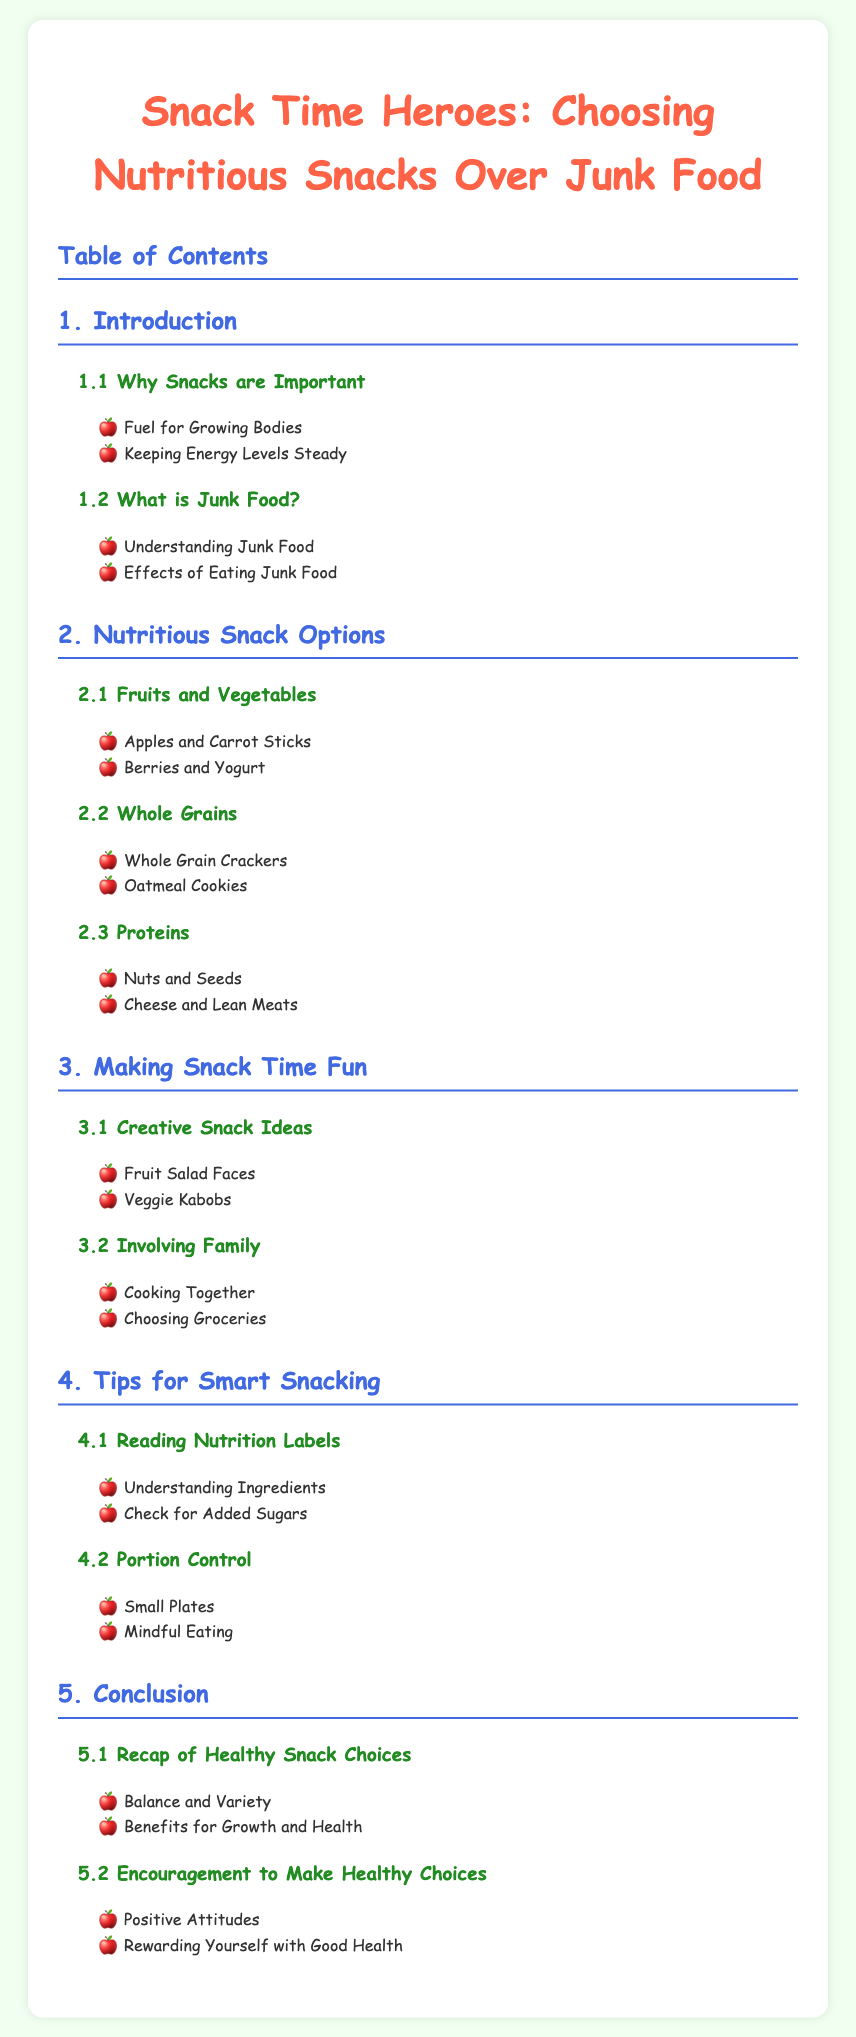What is the title of the document? The title of the document is found at the top and is "Snack Time Heroes: Choosing Nutritious Snacks Over Junk Food."
Answer: Snack Time Heroes: Choosing Nutritious Snacks Over Junk Food How many main sections are in the Table of Contents? The main sections are numbered from 1 to 5, which indicates there are five sections.
Answer: 5 What is one example of nutritious snacks mentioned under "Fruits and Vegetables"? Under "Fruits and Vegetables," one example provided is "Apples and Carrot Sticks."
Answer: Apples and Carrot Sticks What is one creative snack idea mentioned in the document? One creative snack idea listed is "Fruit Salad Faces."
Answer: Fruit Salad Faces What is a tip for smart snacking regarding portion control? The document suggests using "Small Plates" as a tip for portion control.
Answer: Small Plates What should you check for when reading nutrition labels? When reading nutrition labels, it is important to "Check for Added Sugars."
Answer: Check for Added Sugars 